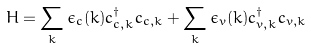<formula> <loc_0><loc_0><loc_500><loc_500>H = \sum _ { k } \epsilon _ { c } ( k ) c _ { c , { k } } ^ { \dagger } c _ { c , { k } } + \sum _ { k } \epsilon _ { v } ( k ) c _ { v , { k } } ^ { \dagger } c _ { v , { k } }</formula> 